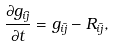<formula> <loc_0><loc_0><loc_500><loc_500>\frac { \partial g _ { i \bar { j } } } { \partial t } = g _ { i \bar { j } } - R _ { i \bar { j } } ,</formula> 